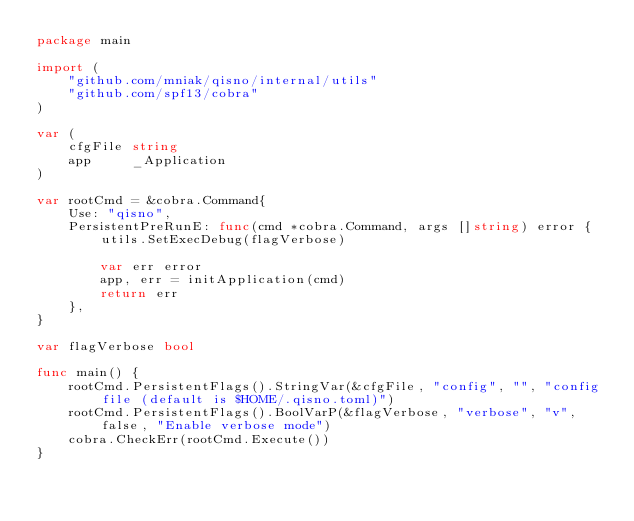Convert code to text. <code><loc_0><loc_0><loc_500><loc_500><_Go_>package main

import (
	"github.com/mniak/qisno/internal/utils"
	"github.com/spf13/cobra"
)

var (
	cfgFile string
	app     _Application
)

var rootCmd = &cobra.Command{
	Use: "qisno",
	PersistentPreRunE: func(cmd *cobra.Command, args []string) error {
		utils.SetExecDebug(flagVerbose)

		var err error
		app, err = initApplication(cmd)
		return err
	},
}

var flagVerbose bool

func main() {
	rootCmd.PersistentFlags().StringVar(&cfgFile, "config", "", "config file (default is $HOME/.qisno.toml)")
	rootCmd.PersistentFlags().BoolVarP(&flagVerbose, "verbose", "v", false, "Enable verbose mode")
	cobra.CheckErr(rootCmd.Execute())
}
</code> 